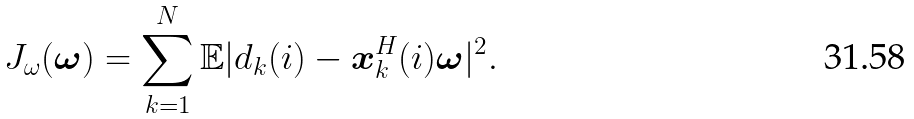<formula> <loc_0><loc_0><loc_500><loc_500>{ J _ { \omega } ( { \boldsymbol \omega } ) } = \sum _ { k = 1 } ^ { N } { \mathbb { E } | { d _ { k } ( i ) } - { \boldsymbol x _ { k } ^ { H } ( i ) } { \boldsymbol \omega } | ^ { 2 } } .</formula> 